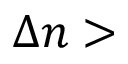Convert formula to latex. <formula><loc_0><loc_0><loc_500><loc_500>{ \Delta } n ></formula> 